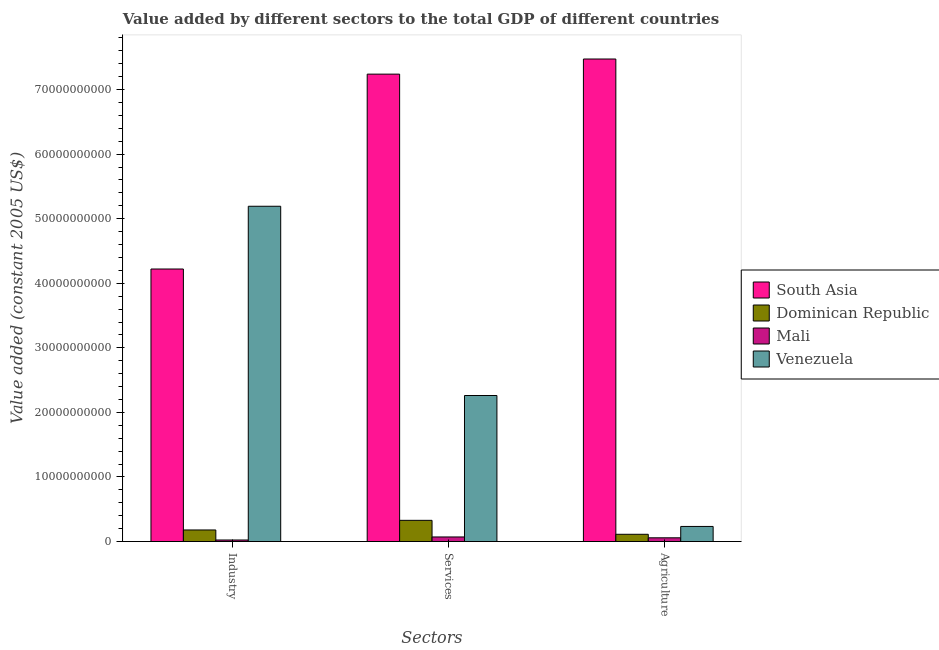Are the number of bars on each tick of the X-axis equal?
Give a very brief answer. Yes. How many bars are there on the 3rd tick from the right?
Your response must be concise. 4. What is the label of the 1st group of bars from the left?
Keep it short and to the point. Industry. What is the value added by industrial sector in Venezuela?
Offer a very short reply. 5.19e+1. Across all countries, what is the maximum value added by industrial sector?
Provide a short and direct response. 5.19e+1. Across all countries, what is the minimum value added by industrial sector?
Ensure brevity in your answer.  2.43e+08. In which country was the value added by services maximum?
Your answer should be compact. South Asia. In which country was the value added by services minimum?
Give a very brief answer. Mali. What is the total value added by services in the graph?
Ensure brevity in your answer.  9.90e+1. What is the difference between the value added by agricultural sector in Dominican Republic and that in Venezuela?
Provide a succinct answer. -1.22e+09. What is the difference between the value added by industrial sector in South Asia and the value added by services in Mali?
Provide a succinct answer. 4.15e+1. What is the average value added by agricultural sector per country?
Your response must be concise. 1.97e+1. What is the difference between the value added by agricultural sector and value added by industrial sector in Venezuela?
Your answer should be compact. -4.96e+1. In how many countries, is the value added by services greater than 34000000000 US$?
Your answer should be compact. 1. What is the ratio of the value added by agricultural sector in Venezuela to that in South Asia?
Offer a terse response. 0.03. What is the difference between the highest and the second highest value added by agricultural sector?
Your response must be concise. 7.24e+1. What is the difference between the highest and the lowest value added by industrial sector?
Your answer should be very brief. 5.17e+1. What does the 2nd bar from the left in Services represents?
Offer a terse response. Dominican Republic. How many bars are there?
Provide a short and direct response. 12. Are all the bars in the graph horizontal?
Your answer should be compact. No. How many countries are there in the graph?
Make the answer very short. 4. Does the graph contain grids?
Make the answer very short. No. How many legend labels are there?
Your response must be concise. 4. How are the legend labels stacked?
Give a very brief answer. Vertical. What is the title of the graph?
Offer a terse response. Value added by different sectors to the total GDP of different countries. What is the label or title of the X-axis?
Your response must be concise. Sectors. What is the label or title of the Y-axis?
Offer a very short reply. Value added (constant 2005 US$). What is the Value added (constant 2005 US$) in South Asia in Industry?
Provide a succinct answer. 4.22e+1. What is the Value added (constant 2005 US$) in Dominican Republic in Industry?
Ensure brevity in your answer.  1.80e+09. What is the Value added (constant 2005 US$) of Mali in Industry?
Your response must be concise. 2.43e+08. What is the Value added (constant 2005 US$) in Venezuela in Industry?
Your answer should be very brief. 5.19e+1. What is the Value added (constant 2005 US$) of South Asia in Services?
Give a very brief answer. 7.24e+1. What is the Value added (constant 2005 US$) of Dominican Republic in Services?
Ensure brevity in your answer.  3.29e+09. What is the Value added (constant 2005 US$) of Mali in Services?
Keep it short and to the point. 7.14e+08. What is the Value added (constant 2005 US$) of Venezuela in Services?
Give a very brief answer. 2.26e+1. What is the Value added (constant 2005 US$) in South Asia in Agriculture?
Provide a succinct answer. 7.47e+1. What is the Value added (constant 2005 US$) of Dominican Republic in Agriculture?
Offer a very short reply. 1.13e+09. What is the Value added (constant 2005 US$) in Mali in Agriculture?
Ensure brevity in your answer.  5.81e+08. What is the Value added (constant 2005 US$) of Venezuela in Agriculture?
Ensure brevity in your answer.  2.34e+09. Across all Sectors, what is the maximum Value added (constant 2005 US$) in South Asia?
Give a very brief answer. 7.47e+1. Across all Sectors, what is the maximum Value added (constant 2005 US$) of Dominican Republic?
Ensure brevity in your answer.  3.29e+09. Across all Sectors, what is the maximum Value added (constant 2005 US$) in Mali?
Keep it short and to the point. 7.14e+08. Across all Sectors, what is the maximum Value added (constant 2005 US$) in Venezuela?
Offer a very short reply. 5.19e+1. Across all Sectors, what is the minimum Value added (constant 2005 US$) in South Asia?
Your answer should be very brief. 4.22e+1. Across all Sectors, what is the minimum Value added (constant 2005 US$) of Dominican Republic?
Ensure brevity in your answer.  1.13e+09. Across all Sectors, what is the minimum Value added (constant 2005 US$) in Mali?
Make the answer very short. 2.43e+08. Across all Sectors, what is the minimum Value added (constant 2005 US$) in Venezuela?
Provide a short and direct response. 2.34e+09. What is the total Value added (constant 2005 US$) of South Asia in the graph?
Provide a succinct answer. 1.89e+11. What is the total Value added (constant 2005 US$) in Dominican Republic in the graph?
Provide a short and direct response. 6.21e+09. What is the total Value added (constant 2005 US$) in Mali in the graph?
Your response must be concise. 1.54e+09. What is the total Value added (constant 2005 US$) in Venezuela in the graph?
Ensure brevity in your answer.  7.69e+1. What is the difference between the Value added (constant 2005 US$) in South Asia in Industry and that in Services?
Your answer should be very brief. -3.02e+1. What is the difference between the Value added (constant 2005 US$) of Dominican Republic in Industry and that in Services?
Provide a short and direct response. -1.49e+09. What is the difference between the Value added (constant 2005 US$) of Mali in Industry and that in Services?
Make the answer very short. -4.71e+08. What is the difference between the Value added (constant 2005 US$) of Venezuela in Industry and that in Services?
Make the answer very short. 2.93e+1. What is the difference between the Value added (constant 2005 US$) of South Asia in Industry and that in Agriculture?
Keep it short and to the point. -3.25e+1. What is the difference between the Value added (constant 2005 US$) of Dominican Republic in Industry and that in Agriculture?
Your answer should be very brief. 6.69e+08. What is the difference between the Value added (constant 2005 US$) of Mali in Industry and that in Agriculture?
Make the answer very short. -3.39e+08. What is the difference between the Value added (constant 2005 US$) of Venezuela in Industry and that in Agriculture?
Your response must be concise. 4.96e+1. What is the difference between the Value added (constant 2005 US$) of South Asia in Services and that in Agriculture?
Ensure brevity in your answer.  -2.34e+09. What is the difference between the Value added (constant 2005 US$) of Dominican Republic in Services and that in Agriculture?
Give a very brief answer. 2.16e+09. What is the difference between the Value added (constant 2005 US$) of Mali in Services and that in Agriculture?
Offer a very short reply. 1.32e+08. What is the difference between the Value added (constant 2005 US$) of Venezuela in Services and that in Agriculture?
Keep it short and to the point. 2.03e+1. What is the difference between the Value added (constant 2005 US$) of South Asia in Industry and the Value added (constant 2005 US$) of Dominican Republic in Services?
Offer a terse response. 3.89e+1. What is the difference between the Value added (constant 2005 US$) of South Asia in Industry and the Value added (constant 2005 US$) of Mali in Services?
Your answer should be compact. 4.15e+1. What is the difference between the Value added (constant 2005 US$) of South Asia in Industry and the Value added (constant 2005 US$) of Venezuela in Services?
Ensure brevity in your answer.  1.96e+1. What is the difference between the Value added (constant 2005 US$) in Dominican Republic in Industry and the Value added (constant 2005 US$) in Mali in Services?
Ensure brevity in your answer.  1.08e+09. What is the difference between the Value added (constant 2005 US$) in Dominican Republic in Industry and the Value added (constant 2005 US$) in Venezuela in Services?
Make the answer very short. -2.08e+1. What is the difference between the Value added (constant 2005 US$) of Mali in Industry and the Value added (constant 2005 US$) of Venezuela in Services?
Ensure brevity in your answer.  -2.24e+1. What is the difference between the Value added (constant 2005 US$) in South Asia in Industry and the Value added (constant 2005 US$) in Dominican Republic in Agriculture?
Provide a short and direct response. 4.11e+1. What is the difference between the Value added (constant 2005 US$) in South Asia in Industry and the Value added (constant 2005 US$) in Mali in Agriculture?
Ensure brevity in your answer.  4.16e+1. What is the difference between the Value added (constant 2005 US$) of South Asia in Industry and the Value added (constant 2005 US$) of Venezuela in Agriculture?
Your answer should be very brief. 3.99e+1. What is the difference between the Value added (constant 2005 US$) in Dominican Republic in Industry and the Value added (constant 2005 US$) in Mali in Agriculture?
Provide a succinct answer. 1.21e+09. What is the difference between the Value added (constant 2005 US$) of Dominican Republic in Industry and the Value added (constant 2005 US$) of Venezuela in Agriculture?
Ensure brevity in your answer.  -5.46e+08. What is the difference between the Value added (constant 2005 US$) of Mali in Industry and the Value added (constant 2005 US$) of Venezuela in Agriculture?
Provide a short and direct response. -2.10e+09. What is the difference between the Value added (constant 2005 US$) in South Asia in Services and the Value added (constant 2005 US$) in Dominican Republic in Agriculture?
Ensure brevity in your answer.  7.13e+1. What is the difference between the Value added (constant 2005 US$) of South Asia in Services and the Value added (constant 2005 US$) of Mali in Agriculture?
Make the answer very short. 7.18e+1. What is the difference between the Value added (constant 2005 US$) of South Asia in Services and the Value added (constant 2005 US$) of Venezuela in Agriculture?
Give a very brief answer. 7.01e+1. What is the difference between the Value added (constant 2005 US$) of Dominican Republic in Services and the Value added (constant 2005 US$) of Mali in Agriculture?
Your response must be concise. 2.71e+09. What is the difference between the Value added (constant 2005 US$) in Dominican Republic in Services and the Value added (constant 2005 US$) in Venezuela in Agriculture?
Make the answer very short. 9.46e+08. What is the difference between the Value added (constant 2005 US$) in Mali in Services and the Value added (constant 2005 US$) in Venezuela in Agriculture?
Your answer should be compact. -1.63e+09. What is the average Value added (constant 2005 US$) of South Asia per Sectors?
Provide a succinct answer. 6.31e+1. What is the average Value added (constant 2005 US$) of Dominican Republic per Sectors?
Provide a succinct answer. 2.07e+09. What is the average Value added (constant 2005 US$) in Mali per Sectors?
Give a very brief answer. 5.13e+08. What is the average Value added (constant 2005 US$) in Venezuela per Sectors?
Provide a short and direct response. 2.56e+1. What is the difference between the Value added (constant 2005 US$) of South Asia and Value added (constant 2005 US$) of Dominican Republic in Industry?
Keep it short and to the point. 4.04e+1. What is the difference between the Value added (constant 2005 US$) in South Asia and Value added (constant 2005 US$) in Mali in Industry?
Make the answer very short. 4.20e+1. What is the difference between the Value added (constant 2005 US$) of South Asia and Value added (constant 2005 US$) of Venezuela in Industry?
Offer a terse response. -9.72e+09. What is the difference between the Value added (constant 2005 US$) of Dominican Republic and Value added (constant 2005 US$) of Mali in Industry?
Make the answer very short. 1.55e+09. What is the difference between the Value added (constant 2005 US$) of Dominican Republic and Value added (constant 2005 US$) of Venezuela in Industry?
Provide a succinct answer. -5.01e+1. What is the difference between the Value added (constant 2005 US$) in Mali and Value added (constant 2005 US$) in Venezuela in Industry?
Your response must be concise. -5.17e+1. What is the difference between the Value added (constant 2005 US$) of South Asia and Value added (constant 2005 US$) of Dominican Republic in Services?
Provide a succinct answer. 6.91e+1. What is the difference between the Value added (constant 2005 US$) in South Asia and Value added (constant 2005 US$) in Mali in Services?
Your response must be concise. 7.17e+1. What is the difference between the Value added (constant 2005 US$) of South Asia and Value added (constant 2005 US$) of Venezuela in Services?
Make the answer very short. 4.98e+1. What is the difference between the Value added (constant 2005 US$) of Dominican Republic and Value added (constant 2005 US$) of Mali in Services?
Your answer should be compact. 2.57e+09. What is the difference between the Value added (constant 2005 US$) in Dominican Republic and Value added (constant 2005 US$) in Venezuela in Services?
Offer a very short reply. -1.93e+1. What is the difference between the Value added (constant 2005 US$) of Mali and Value added (constant 2005 US$) of Venezuela in Services?
Your answer should be very brief. -2.19e+1. What is the difference between the Value added (constant 2005 US$) of South Asia and Value added (constant 2005 US$) of Dominican Republic in Agriculture?
Provide a succinct answer. 7.36e+1. What is the difference between the Value added (constant 2005 US$) of South Asia and Value added (constant 2005 US$) of Mali in Agriculture?
Give a very brief answer. 7.42e+1. What is the difference between the Value added (constant 2005 US$) of South Asia and Value added (constant 2005 US$) of Venezuela in Agriculture?
Provide a succinct answer. 7.24e+1. What is the difference between the Value added (constant 2005 US$) in Dominican Republic and Value added (constant 2005 US$) in Mali in Agriculture?
Provide a succinct answer. 5.45e+08. What is the difference between the Value added (constant 2005 US$) in Dominican Republic and Value added (constant 2005 US$) in Venezuela in Agriculture?
Offer a very short reply. -1.22e+09. What is the difference between the Value added (constant 2005 US$) of Mali and Value added (constant 2005 US$) of Venezuela in Agriculture?
Your response must be concise. -1.76e+09. What is the ratio of the Value added (constant 2005 US$) in South Asia in Industry to that in Services?
Provide a succinct answer. 0.58. What is the ratio of the Value added (constant 2005 US$) in Dominican Republic in Industry to that in Services?
Make the answer very short. 0.55. What is the ratio of the Value added (constant 2005 US$) in Mali in Industry to that in Services?
Keep it short and to the point. 0.34. What is the ratio of the Value added (constant 2005 US$) in Venezuela in Industry to that in Services?
Provide a succinct answer. 2.3. What is the ratio of the Value added (constant 2005 US$) in South Asia in Industry to that in Agriculture?
Ensure brevity in your answer.  0.56. What is the ratio of the Value added (constant 2005 US$) in Dominican Republic in Industry to that in Agriculture?
Make the answer very short. 1.59. What is the ratio of the Value added (constant 2005 US$) of Mali in Industry to that in Agriculture?
Keep it short and to the point. 0.42. What is the ratio of the Value added (constant 2005 US$) of Venezuela in Industry to that in Agriculture?
Ensure brevity in your answer.  22.18. What is the ratio of the Value added (constant 2005 US$) of South Asia in Services to that in Agriculture?
Ensure brevity in your answer.  0.97. What is the ratio of the Value added (constant 2005 US$) in Dominican Republic in Services to that in Agriculture?
Keep it short and to the point. 2.92. What is the ratio of the Value added (constant 2005 US$) of Mali in Services to that in Agriculture?
Keep it short and to the point. 1.23. What is the ratio of the Value added (constant 2005 US$) of Venezuela in Services to that in Agriculture?
Keep it short and to the point. 9.66. What is the difference between the highest and the second highest Value added (constant 2005 US$) in South Asia?
Give a very brief answer. 2.34e+09. What is the difference between the highest and the second highest Value added (constant 2005 US$) in Dominican Republic?
Your answer should be very brief. 1.49e+09. What is the difference between the highest and the second highest Value added (constant 2005 US$) in Mali?
Offer a very short reply. 1.32e+08. What is the difference between the highest and the second highest Value added (constant 2005 US$) in Venezuela?
Make the answer very short. 2.93e+1. What is the difference between the highest and the lowest Value added (constant 2005 US$) in South Asia?
Offer a very short reply. 3.25e+1. What is the difference between the highest and the lowest Value added (constant 2005 US$) of Dominican Republic?
Your answer should be compact. 2.16e+09. What is the difference between the highest and the lowest Value added (constant 2005 US$) in Mali?
Offer a terse response. 4.71e+08. What is the difference between the highest and the lowest Value added (constant 2005 US$) in Venezuela?
Make the answer very short. 4.96e+1. 